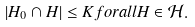Convert formula to latex. <formula><loc_0><loc_0><loc_500><loc_500>| H _ { 0 } \cap H | \leq K f o r a l l H \in \mathcal { H } .</formula> 